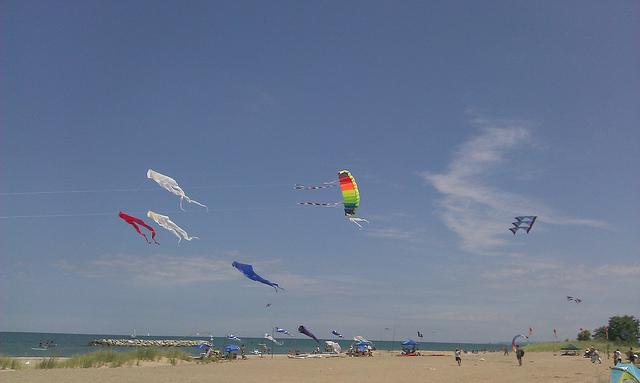Who uses the item in the sky the most? children 